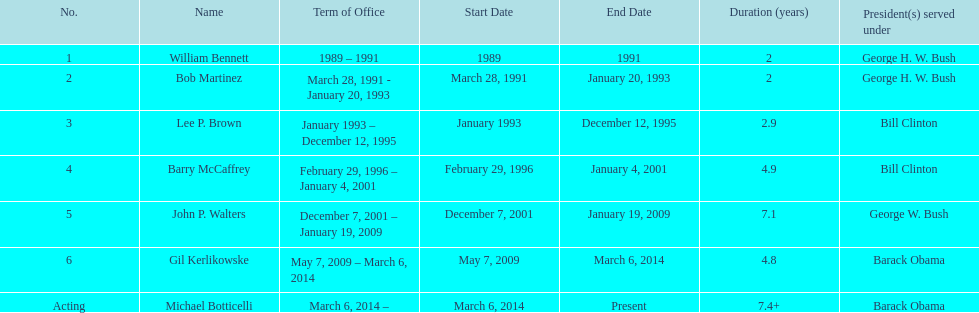What were the number of directors that stayed in office more than three years? 3. 